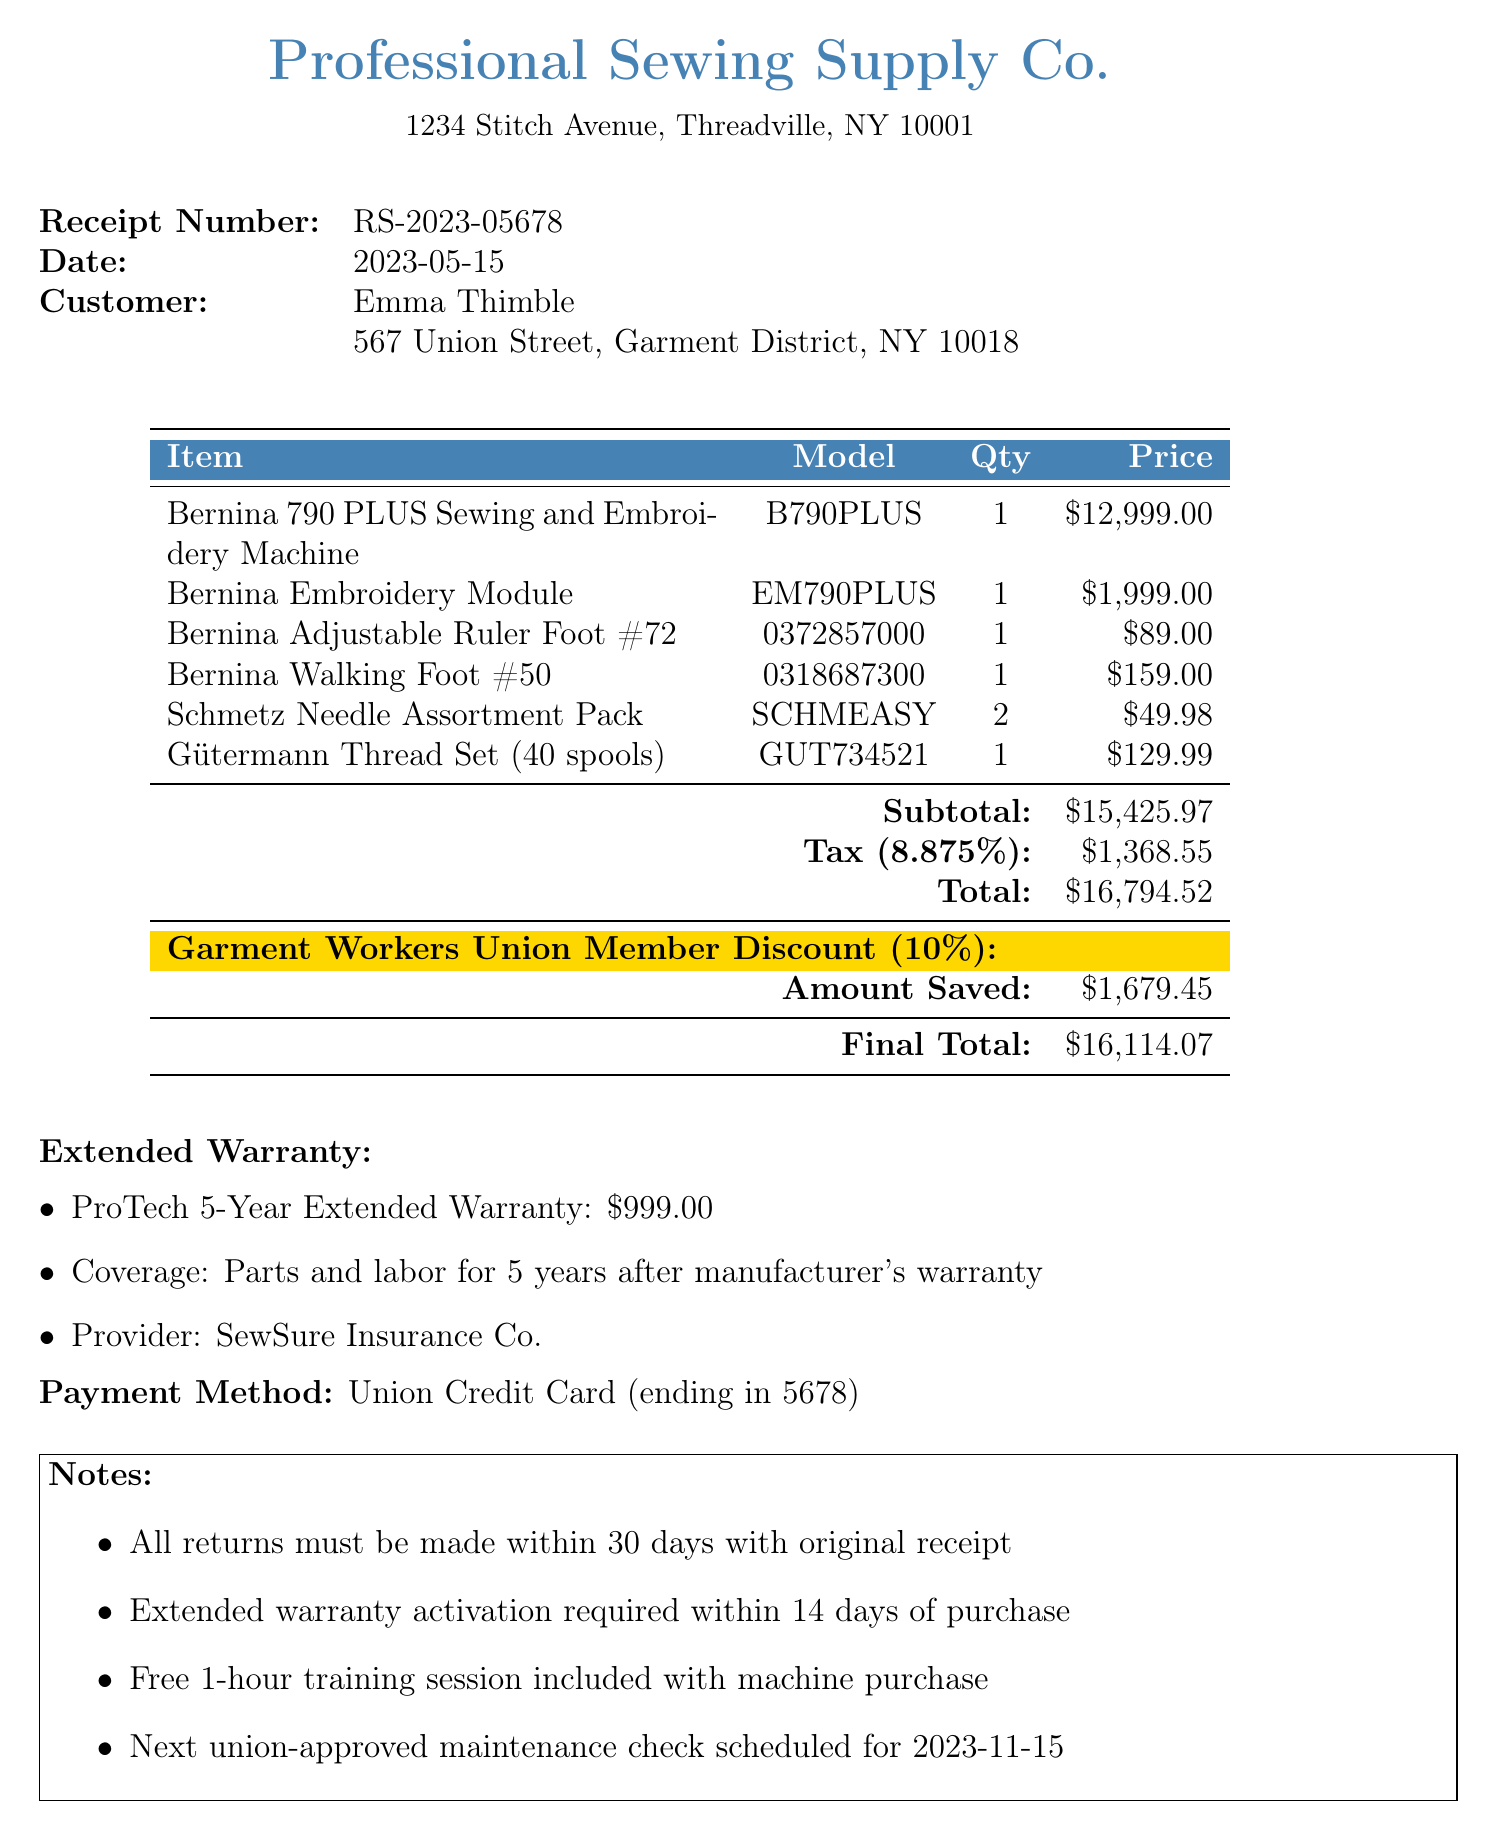What is the receipt number? The receipt number is listed at the top of the document under "Receipt Number."
Answer: RS-2023-05678 What is the date of purchase? The purchase date is mentioned right after the receipt number.
Answer: 2023-05-15 Who is the customer? The customer's name is provided in the document.
Answer: Emma Thimble What is the total amount after the union discount? The final total shows the amount after applying the union discount.
Answer: $16,114.07 What extended warranty was purchased? This information is detailed under the extended warranty section of the document.
Answer: ProTech 5-Year Extended Warranty What is the tax rate applied to the purchase? The tax rate is specified in the document, right before the total amount.
Answer: 8.875% How much was saved with the union discount? The amount saved through the union discount is stated in the discount section.
Answer: $1,679.45 What is included in the training session? The notes section mentions the training session included with the machine purchase.
Answer: Free 1-hour training session When is the next scheduled maintenance check? The date for the next maintenance check is mentioned in the notes.
Answer: 2023-11-15 